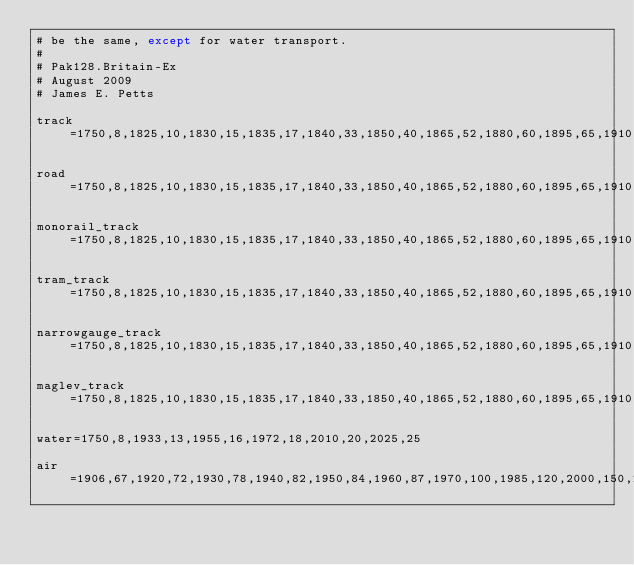<code> <loc_0><loc_0><loc_500><loc_500><_SQL_># be the same, except for water transport.
#
# Pak128.Britain-Ex
# August 2009
# James E. Petts

track=1750,8,1825,10,1830,15,1835,17,1840,33,1850,40,1865,52,1880,60,1895,65,1910,67,1920,72,1930,78,1940,82,1950,84,1960,87,1970,100,1985,120,2000,150,2030,175

road=1750,8,1825,10,1830,15,1835,17,1840,33,1850,40,1865,52,1880,60,1895,65,1910,67,1920,72,1930,78,1940,82,1950,84,1960,87,1970,100,1985,120,2000,150,2030,175

monorail_track=1750,8,1825,10,1830,15,1835,17,1840,33,1850,40,1865,52,1880,60,1895,65,1910,67,1920,72,1930,78,1940,82,1950,84,1960,87,1970,100,1985,120,2000,150,2030,175

tram_track=1750,8,1825,10,1830,15,1835,17,1840,33,1850,40,1865,52,1880,60,1895,65,1910,67,1920,72,1930,78,1940,82,1950,84,1960,87,1970,100,1985,120,2000,150,2030,175

narrowgauge_track=1750,8,1825,10,1830,15,1835,17,1840,33,1850,40,1865,52,1880,60,1895,65,1910,67,1920,72,1930,78,1940,82,1950,84,1960,87,1970,100,1985,120,2000,150,2030,175
 
maglev_track=1750,8,1825,10,1830,15,1835,17,1840,33,1850,40,1865,52,1880,60,1895,65,1910,67,1920,72,1930,78,1940,82,1950,84,1960,87,1970,100,1985,120,2000,150,2030,175

water=1750,8,1933,13,1955,16,1972,18,2010,20,2025,25

air=1906,67,1920,72,1930,78,1940,82,1950,84,1960,87,1970,100,1985,120,2000,150,2030,175</code> 